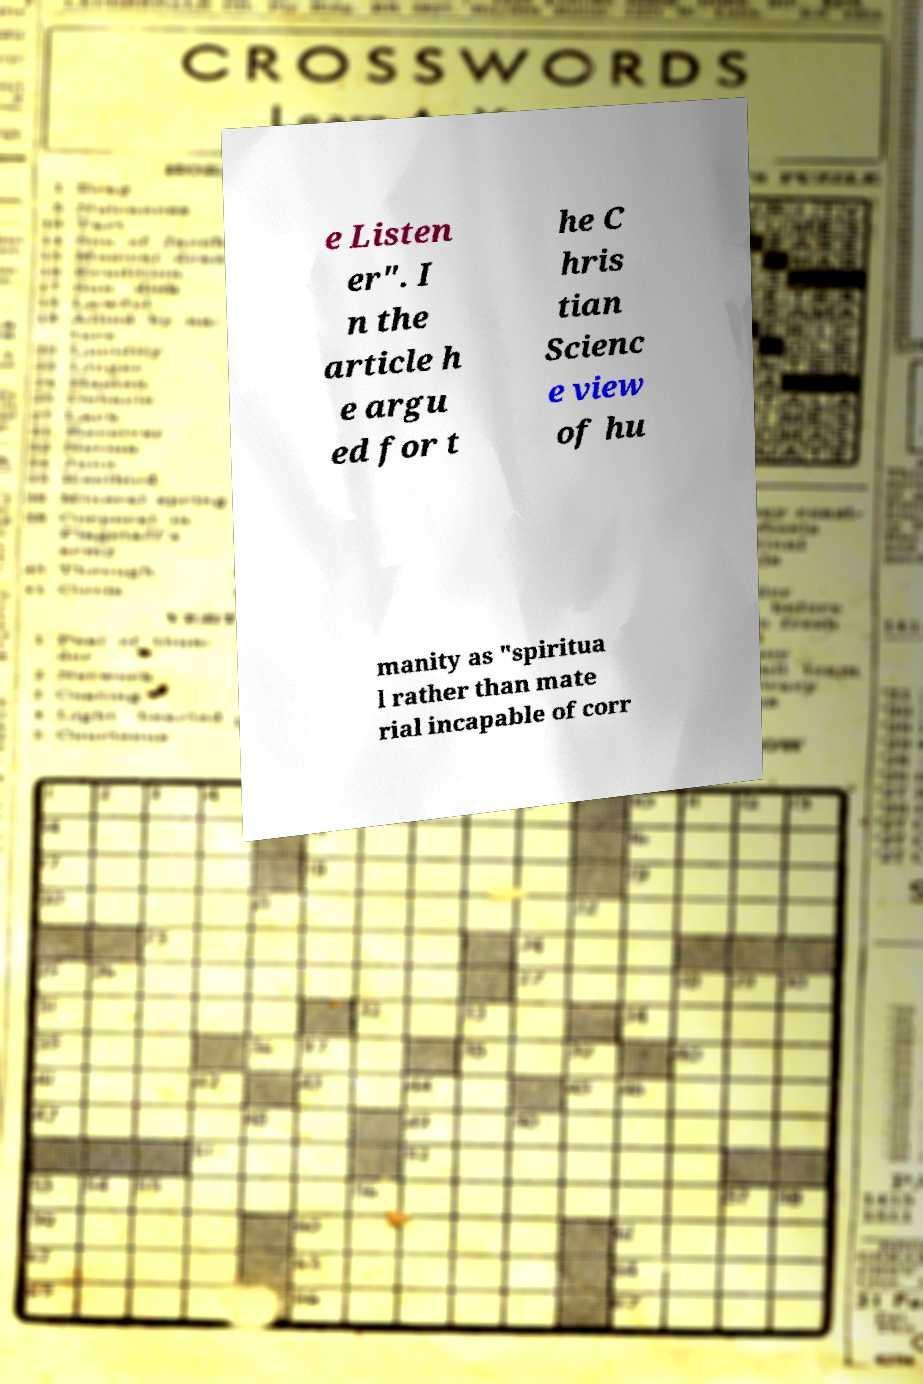Please identify and transcribe the text found in this image. e Listen er". I n the article h e argu ed for t he C hris tian Scienc e view of hu manity as "spiritua l rather than mate rial incapable of corr 